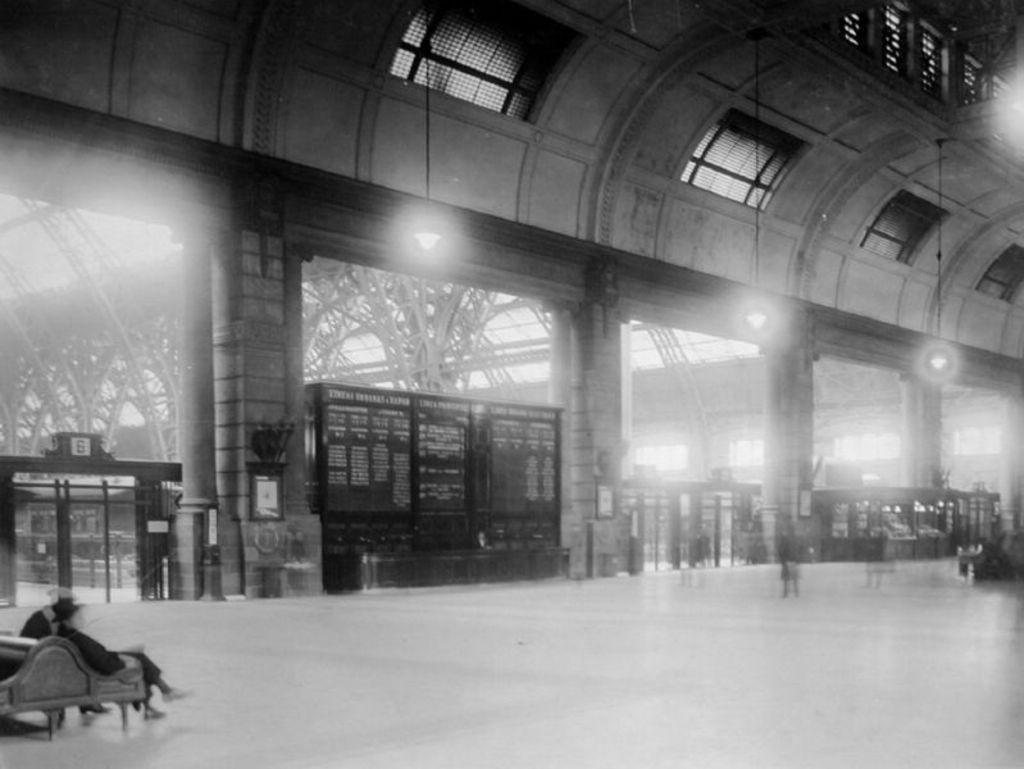In one or two sentences, can you explain what this image depicts? This image consists of a person sitting on a bench. In the background, there is a wall along with buildings. In the middle, there is a board. At the bottom, there is a floor. 